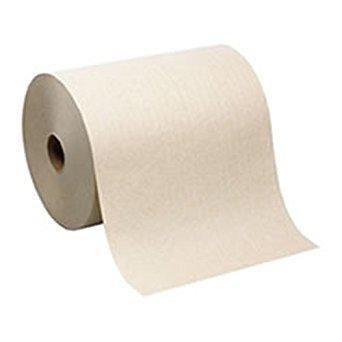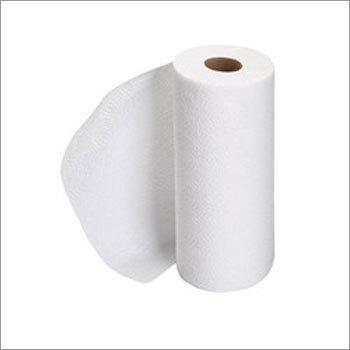The first image is the image on the left, the second image is the image on the right. Examine the images to the left and right. Is the description "There are three rolls of paper" accurate? Answer yes or no. No. 